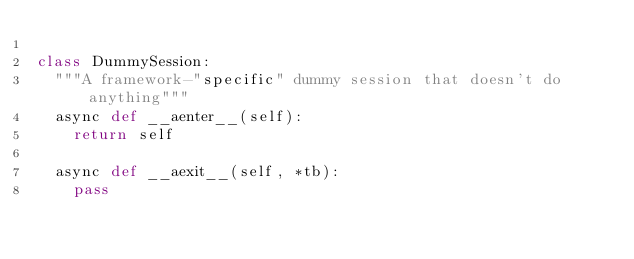Convert code to text. <code><loc_0><loc_0><loc_500><loc_500><_Python_>
class DummySession:
	"""A framework-"specific" dummy session that doesn't do anything"""
	async def __aenter__(self):
		return self

	async def __aexit__(self, *tb):
		pass

</code> 